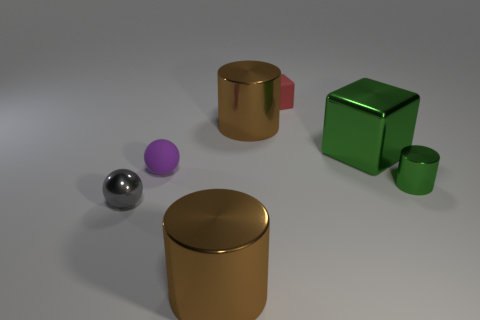Subtract all big brown metallic cylinders. How many cylinders are left? 1 Add 1 big yellow metal spheres. How many objects exist? 8 Subtract all purple spheres. How many spheres are left? 1 Subtract all cylinders. How many objects are left? 4 Subtract 0 red spheres. How many objects are left? 7 Subtract 3 cylinders. How many cylinders are left? 0 Subtract all cyan spheres. Subtract all cyan blocks. How many spheres are left? 2 Subtract all cyan balls. How many green cylinders are left? 1 Subtract all big objects. Subtract all small cyan cylinders. How many objects are left? 4 Add 1 green metallic cylinders. How many green metallic cylinders are left? 2 